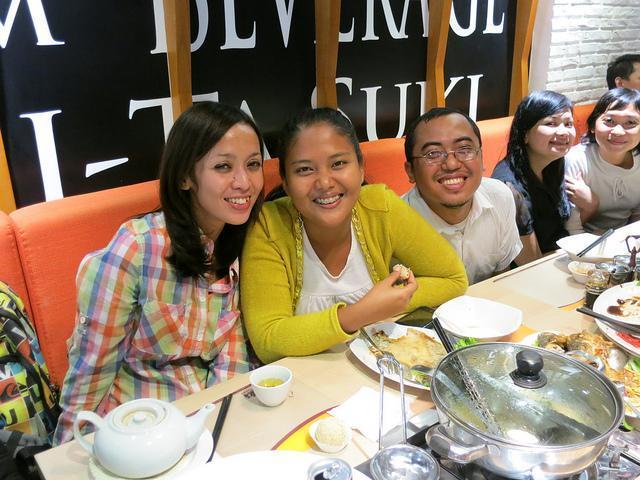How many metal kitchenware are there?
Give a very brief answer. 1. How many dining tables can you see?
Give a very brief answer. 1. How many people are there?
Give a very brief answer. 6. How many bowls can be seen?
Give a very brief answer. 2. 